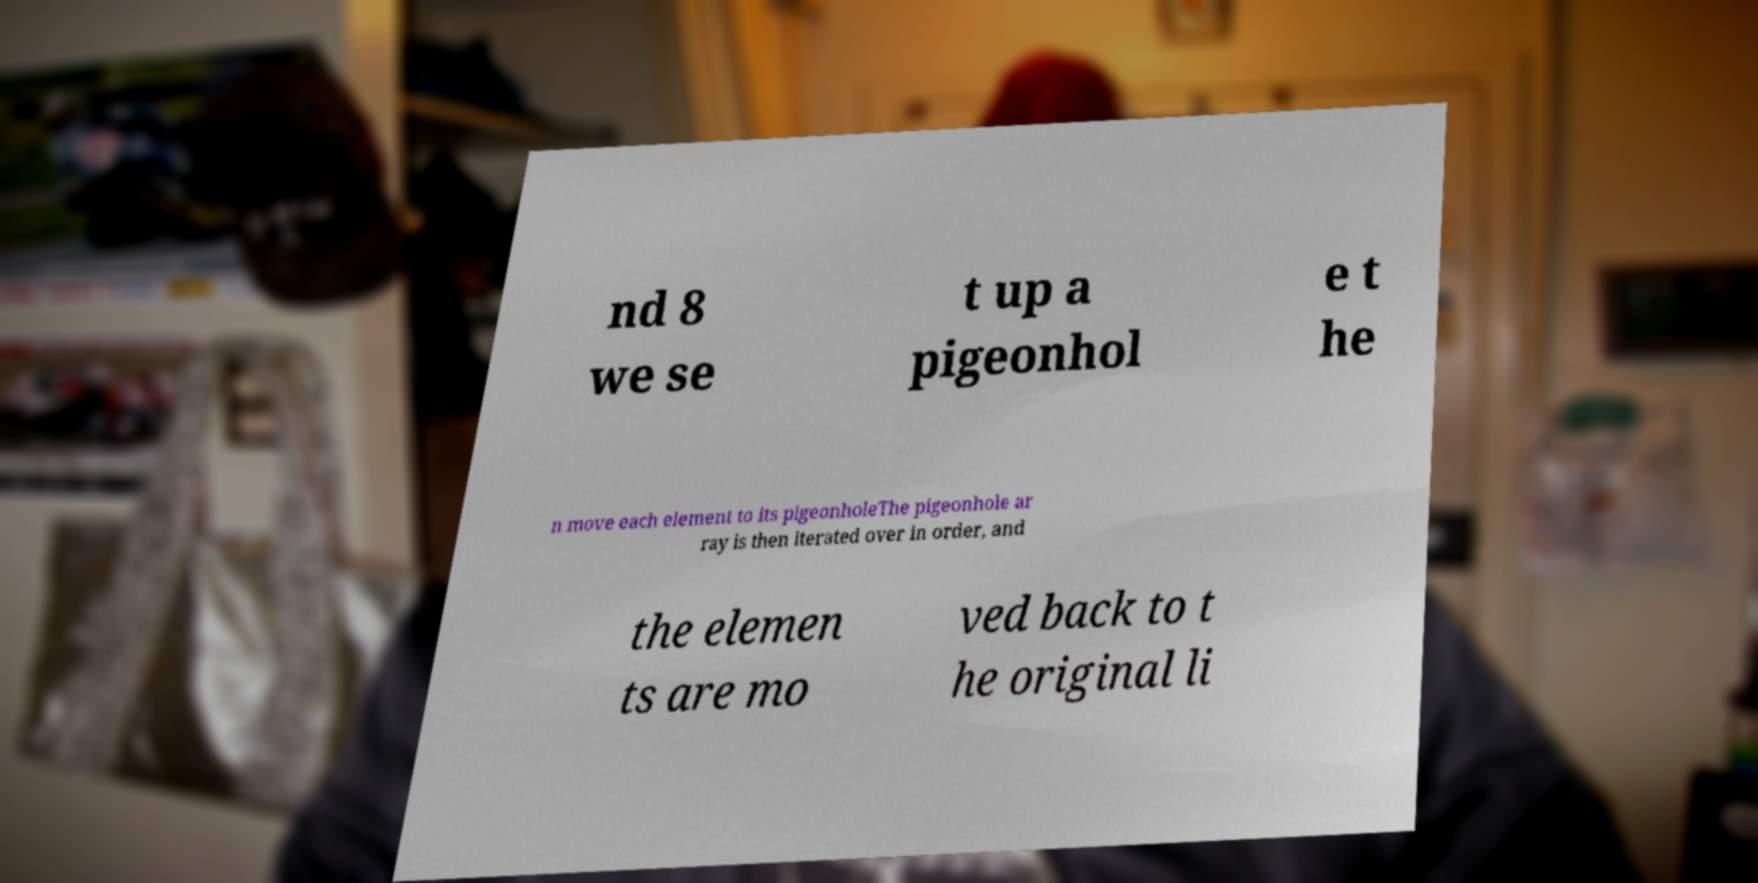Please read and relay the text visible in this image. What does it say? nd 8 we se t up a pigeonhol e t he n move each element to its pigeonholeThe pigeonhole ar ray is then iterated over in order, and the elemen ts are mo ved back to t he original li 